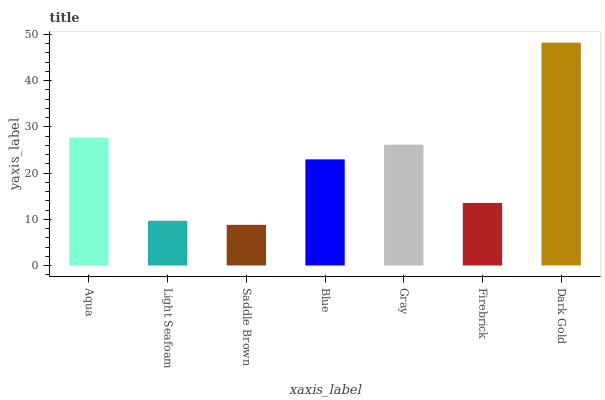Is Saddle Brown the minimum?
Answer yes or no. Yes. Is Dark Gold the maximum?
Answer yes or no. Yes. Is Light Seafoam the minimum?
Answer yes or no. No. Is Light Seafoam the maximum?
Answer yes or no. No. Is Aqua greater than Light Seafoam?
Answer yes or no. Yes. Is Light Seafoam less than Aqua?
Answer yes or no. Yes. Is Light Seafoam greater than Aqua?
Answer yes or no. No. Is Aqua less than Light Seafoam?
Answer yes or no. No. Is Blue the high median?
Answer yes or no. Yes. Is Blue the low median?
Answer yes or no. Yes. Is Saddle Brown the high median?
Answer yes or no. No. Is Dark Gold the low median?
Answer yes or no. No. 